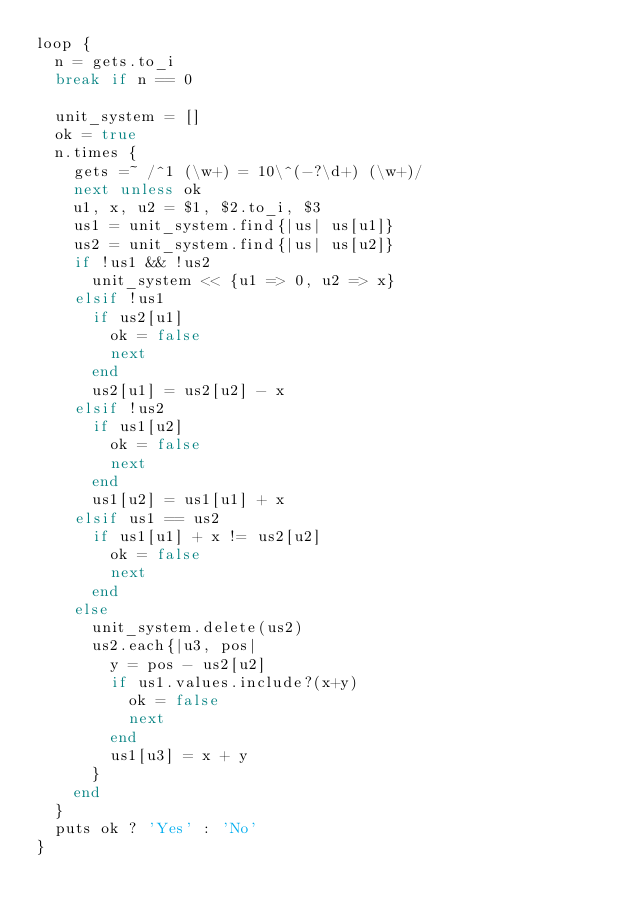<code> <loc_0><loc_0><loc_500><loc_500><_Ruby_>loop {
	n = gets.to_i
	break if n == 0

	unit_system = []
	ok = true
	n.times {
		gets =~ /^1 (\w+) = 10\^(-?\d+) (\w+)/
		next unless ok
		u1, x, u2 = $1, $2.to_i, $3
		us1 = unit_system.find{|us| us[u1]}
		us2 = unit_system.find{|us| us[u2]}
		if !us1 && !us2
			unit_system << {u1 => 0, u2 => x}
		elsif !us1
			if us2[u1]
				ok = false
				next
			end
			us2[u1] = us2[u2] - x	
		elsif !us2
			if us1[u2]
				ok = false
				next
			end
			us1[u2] = us1[u1] + x	
		elsif us1 == us2
			if us1[u1] + x != us2[u2]
				ok = false
				next
			end
		else
			unit_system.delete(us2)
			us2.each{|u3, pos|
				y = pos - us2[u2]
				if us1.values.include?(x+y)
					ok = false
					next
				end
				us1[u3] = x + y
			}
		end
	}
	puts ok ? 'Yes' : 'No'
}</code> 